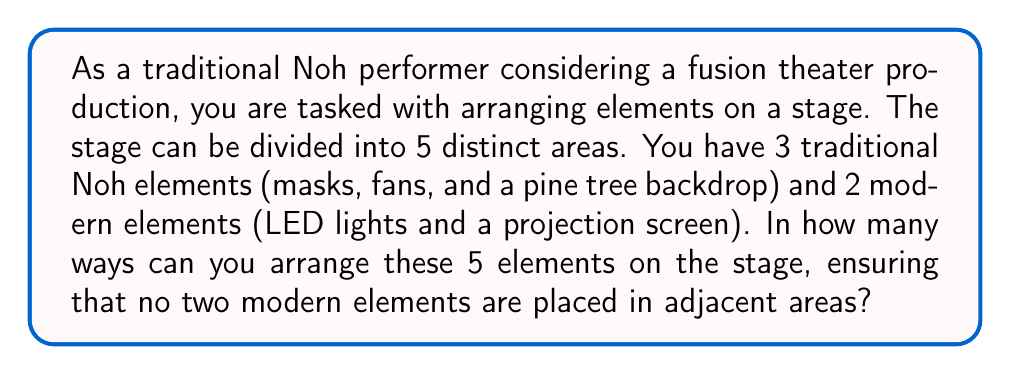Solve this math problem. Let's approach this step-by-step:

1) First, we need to consider the total number of ways to arrange 5 elements in 5 positions. This would be a straightforward permutation: $5! = 120$.

2) However, we need to subtract the arrangements where the two modern elements are adjacent. To count these:
   a) Consider the modern elements as one unit. Now we have 4 units to arrange (3 traditional + 1 combined modern).
   b) Arrange these 4 units: $4! = 24$
   c) The two modern elements can be arranged within their unit in $2! = 2$ ways.

3) So, the number of arrangements with adjacent modern elements is $24 * 2 = 48$.

4) Therefore, the number of valid arrangements is:

   $$\text{Total arrangements} - \text{Arrangements with adjacent modern elements}$$
   $$= 5! - (4! * 2!)$$
   $$= 120 - 48$$
   $$= 72$$

This result represents the number of ways to arrange the traditional and modern elements while maintaining a balance that doesn't overwhelm the traditional aspects, which aligns with the persona of a Noh performer who is cautiously embracing fusion.
Answer: 72 ways 